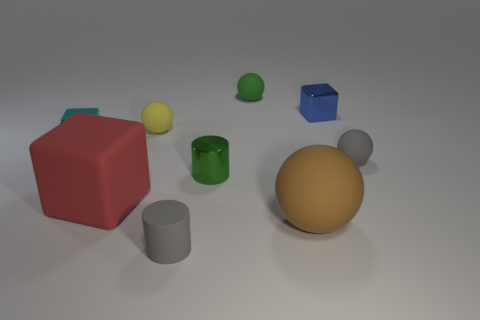What number of things are cylinders behind the large brown rubber ball or tiny rubber blocks? There appears to be one cylindrical object located directly behind the large brown rubber ball. It's a gray cylinder, presenting a simplistic geometric form typical of such shapes. 